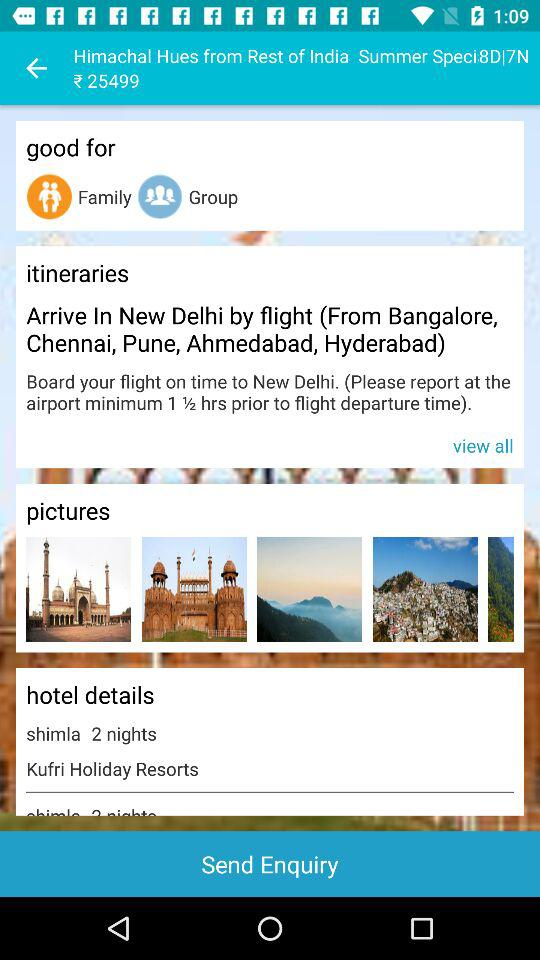What is the name of the hotel? The name of the hotel is "Kufri Holiday Resorts". 